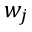Convert formula to latex. <formula><loc_0><loc_0><loc_500><loc_500>w _ { j }</formula> 